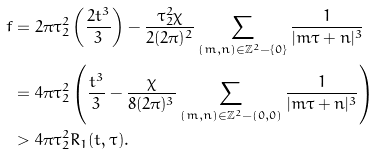Convert formula to latex. <formula><loc_0><loc_0><loc_500><loc_500>f & = 2 \pi \tau _ { 2 } ^ { 2 } \left ( \frac { 2 t ^ { 3 } } { 3 } \right ) - \frac { \tau _ { 2 } ^ { 2 } \chi } { 2 ( 2 \pi ) ^ { 2 } } \sum _ { ( m , n ) \in \mathbb { Z } ^ { 2 } - \{ 0 \} } \frac { 1 } { | m \tau + n | ^ { 3 } } \\ & = 4 \pi \tau _ { 2 } ^ { 2 } \left ( \frac { t ^ { 3 } } { 3 } - \frac { \chi } { 8 ( 2 \pi ) ^ { 3 } } \sum _ { ( m , n ) \in \mathbb { Z } ^ { 2 } - ( 0 , 0 ) } \frac { 1 } { | m \tau + n | ^ { 3 } } \right ) \, \\ & > 4 \pi \tau _ { 2 } ^ { 2 } R _ { 1 } ( t , \tau ) .</formula> 